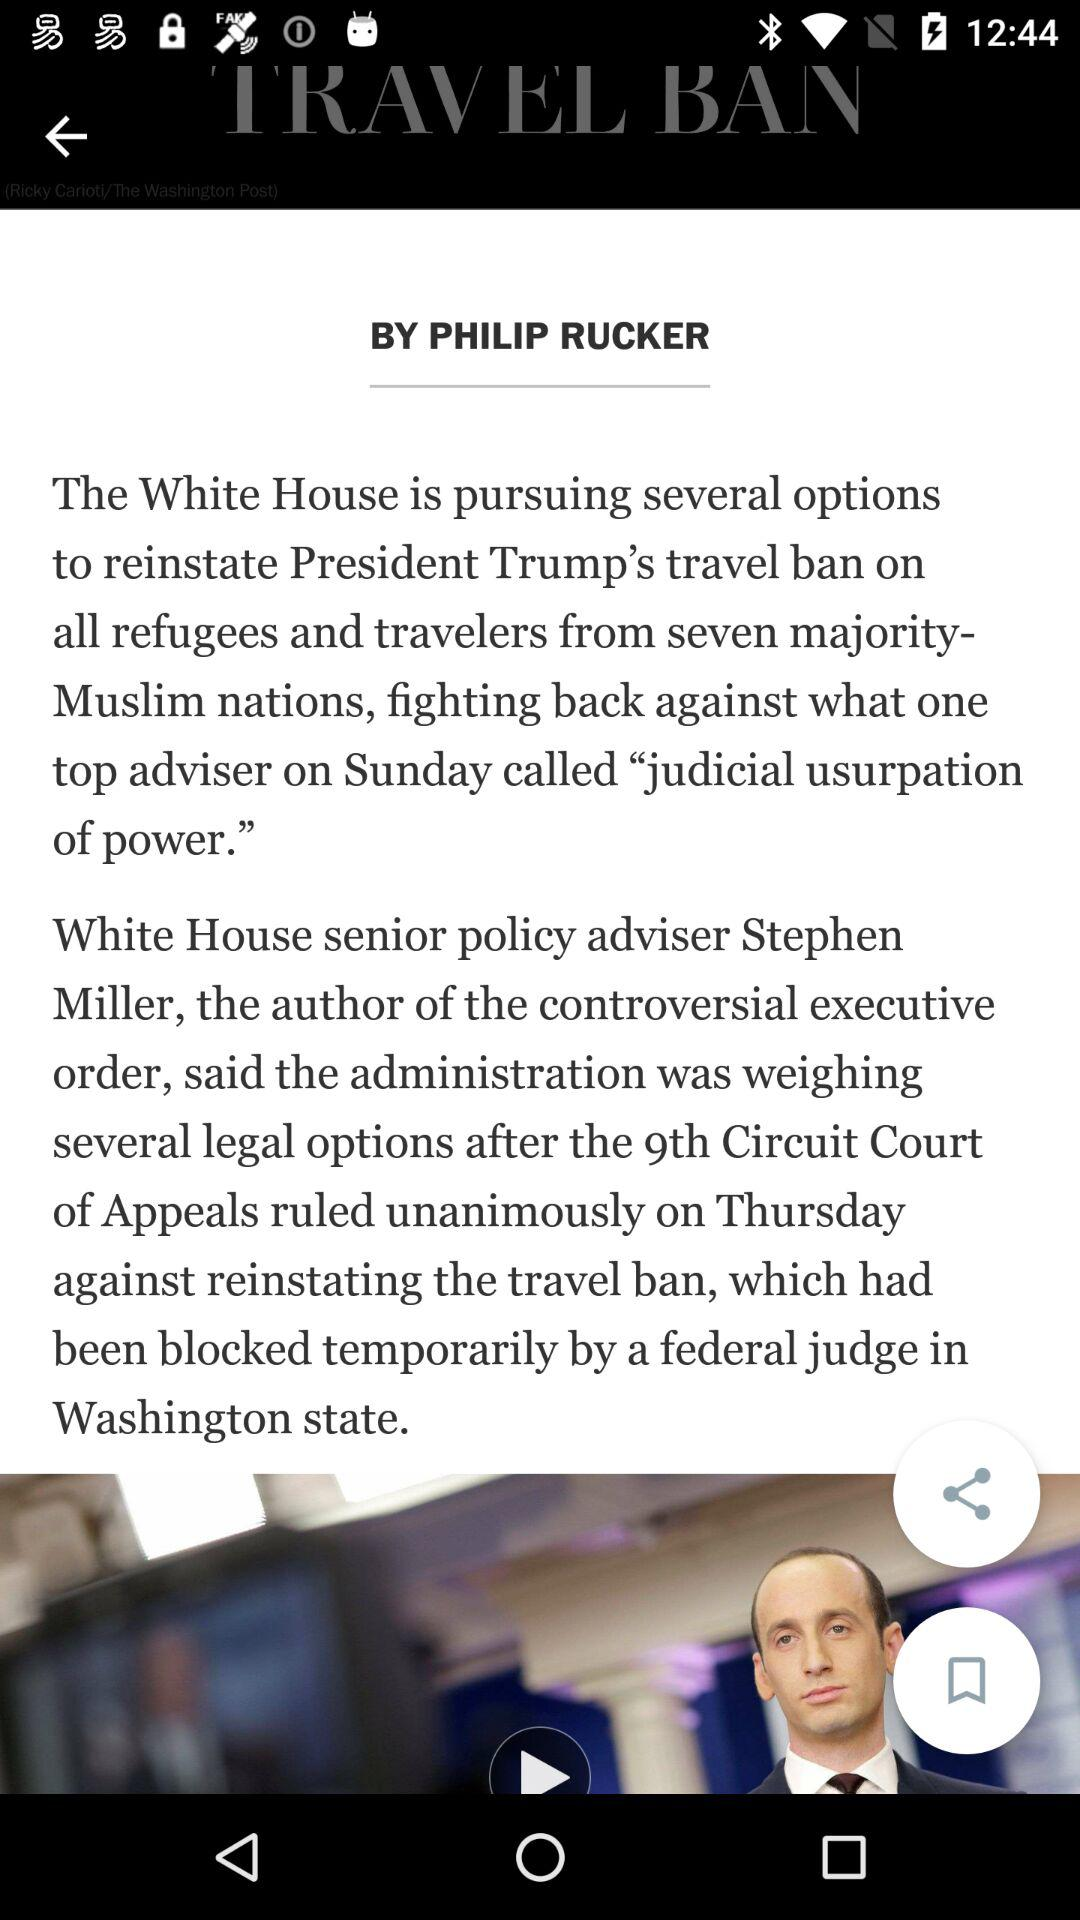When was the article posted?
When the provided information is insufficient, respond with <no answer>. <no answer> 